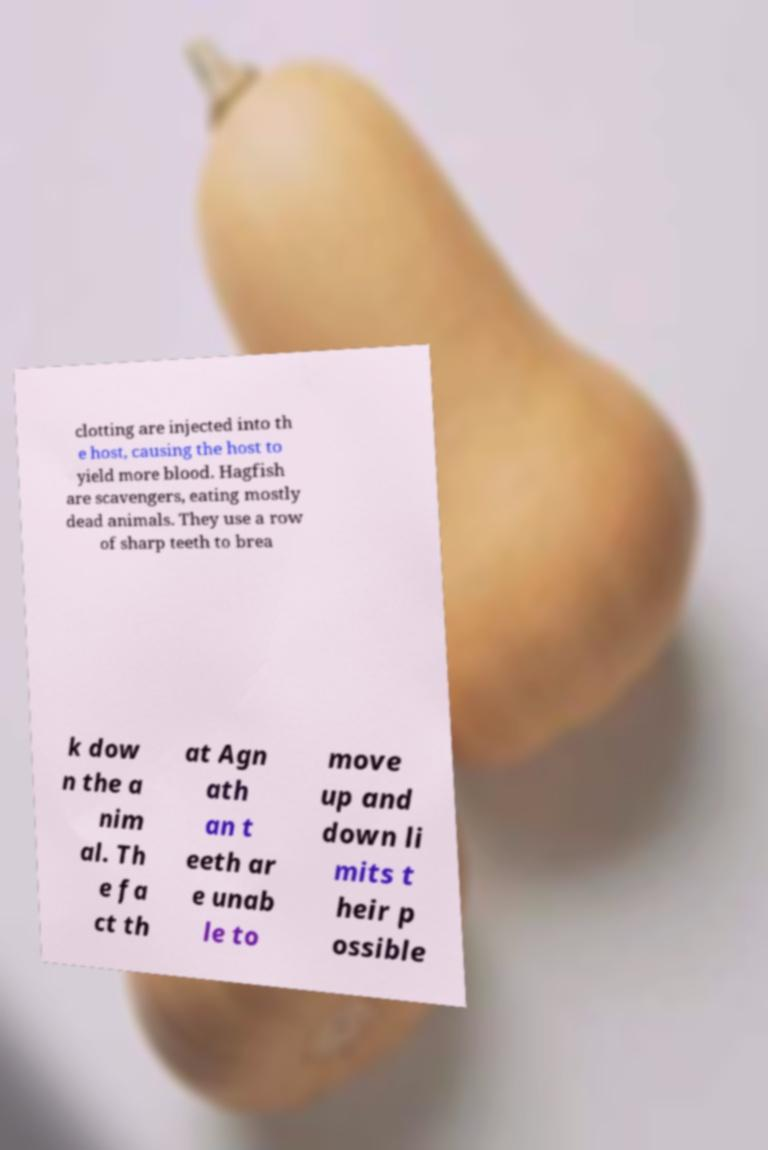What messages or text are displayed in this image? I need them in a readable, typed format. clotting are injected into th e host, causing the host to yield more blood. Hagfish are scavengers, eating mostly dead animals. They use a row of sharp teeth to brea k dow n the a nim al. Th e fa ct th at Agn ath an t eeth ar e unab le to move up and down li mits t heir p ossible 